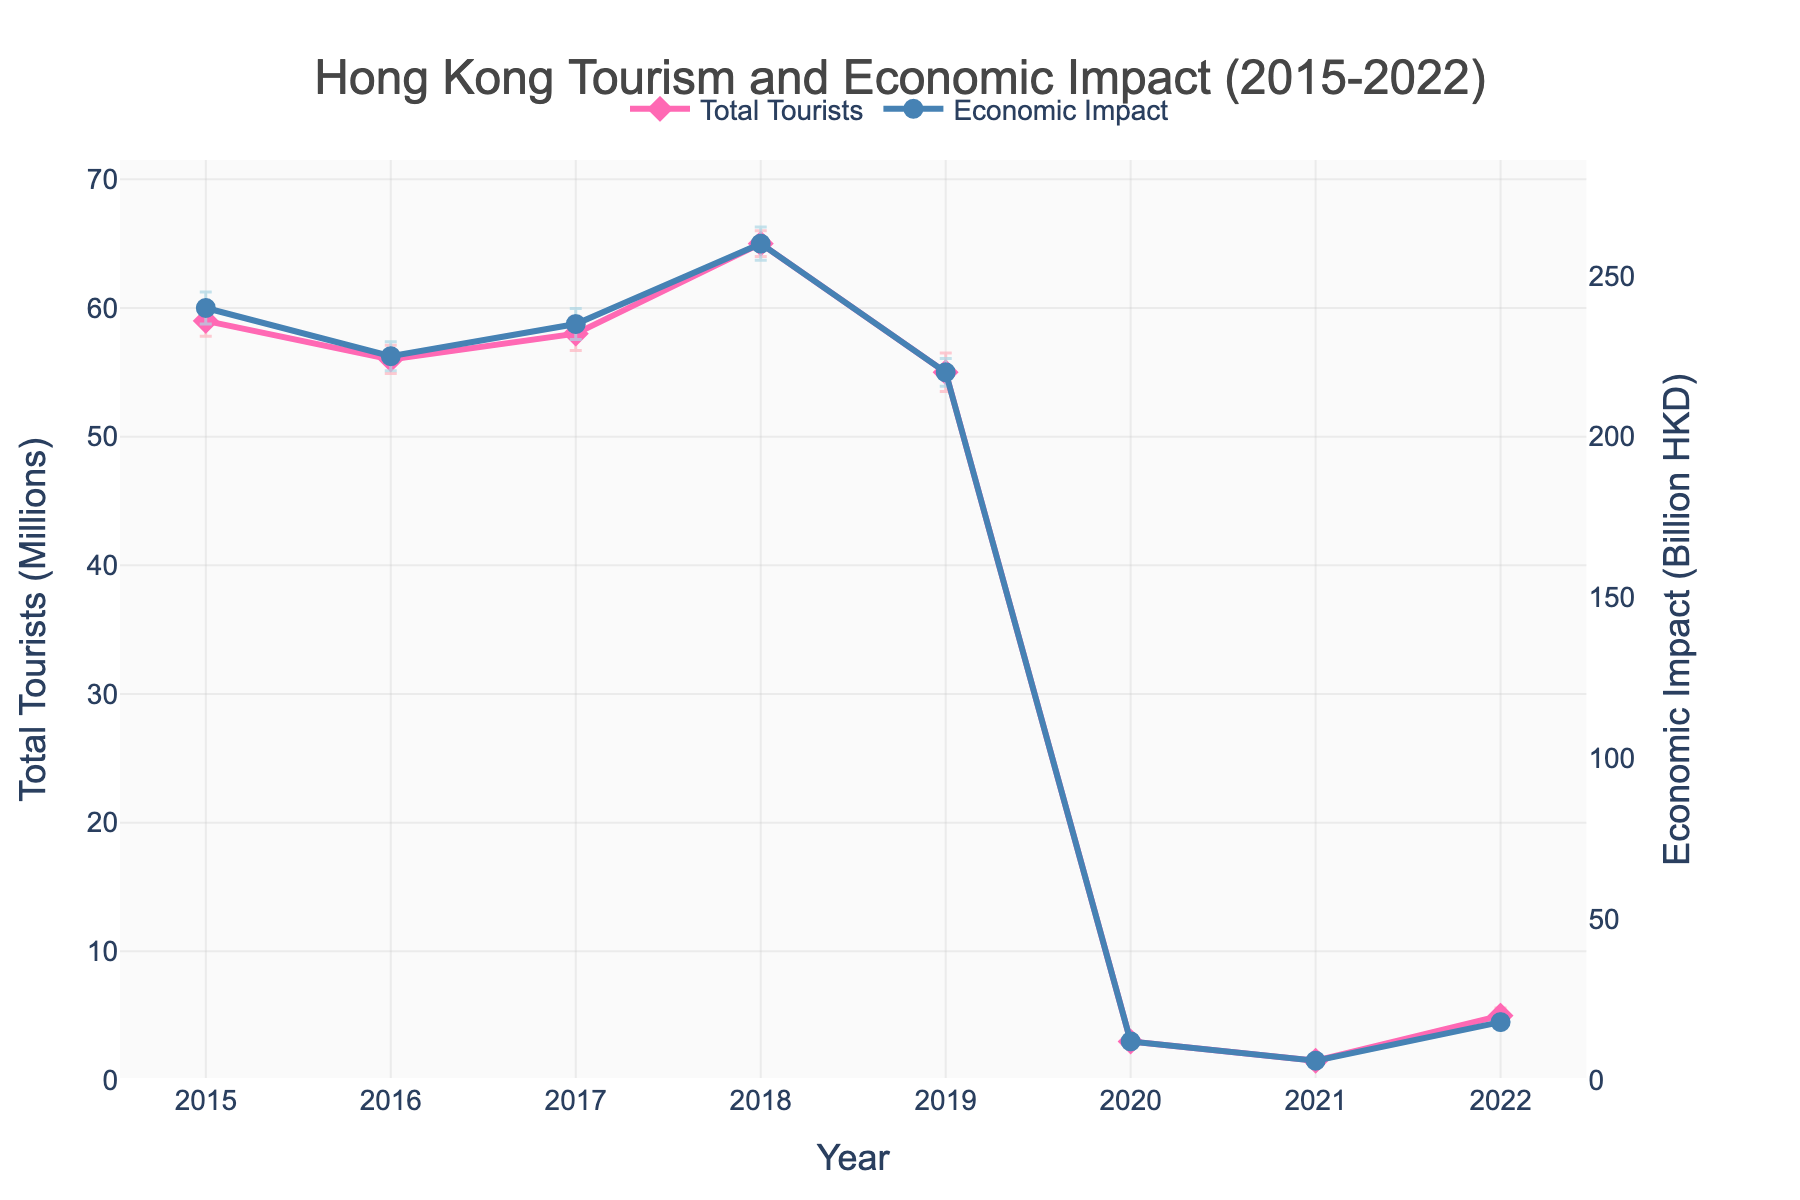What is the title of the plot? The title of the plot is located at the top center and provides a summary of the data shown. The title reads "Hong Kong Tourism and Economic Impact (2015-2022)".
Answer: Hong Kong Tourism and Economic Impact (2015-2022) Which year had the highest total tourists? Observing the line plot for total tourists, the year with the peak point is 2018.
Answer: 2018 What is the range of the y-axis representing total tourists? Looking at the y-axis on the left side of the figure representing total tourists, the minimum value starts at 0, and the maximum value is slightly above 65 million, approximately 70 million.
Answer: 0 to 70 million How does the total number of tourists in 2020 compare to 2021? By comparing the two points on the plot, 2020 had 3 million tourists, whereas 2021 had 1.5 million tourists, indicating a decrease in 2021.
Answer: 2020 had more tourists than 2021 What was the economic impact in 2018, and how does it compare to 2019? The economic impact in 2018 was 260 billion HKD and in 2019 was 220 billion HKD. Therefore, the economic impact decreased by 40 billion HKD from 2018 to 2019.
Answer: It decreased by 40 billion HKD Which year shows the highest economic impact? The year with the highest point on the economic impact plot, located on the right y-axis, is 2018 with an impact of 260 billion HKD.
Answer: 2018 What was the difference in the total number of tourists between 2015 and 2019? The total number of tourists in 2015 was 59 million and in 2019 it was 55 million, showing a decrease of 4 million tourists.
Answer: 4 million In which year did the economic impact significantly drop, showing an unprecedented low value in the plot? The plot indicates a dramatic drop in economic impact in 2020, where the value plummeted to 12 billion HKD.
Answer: 2020 What can be inferred about the trend of total tourists from 2017 to 2019? From 2017 (58 million) to 2018 (65 million), the total tourists increased, but then there was a noticeable drop in 2019 (55 million). Therefore, there was an increase followed by a decrease.
Answer: Increase then decrease 